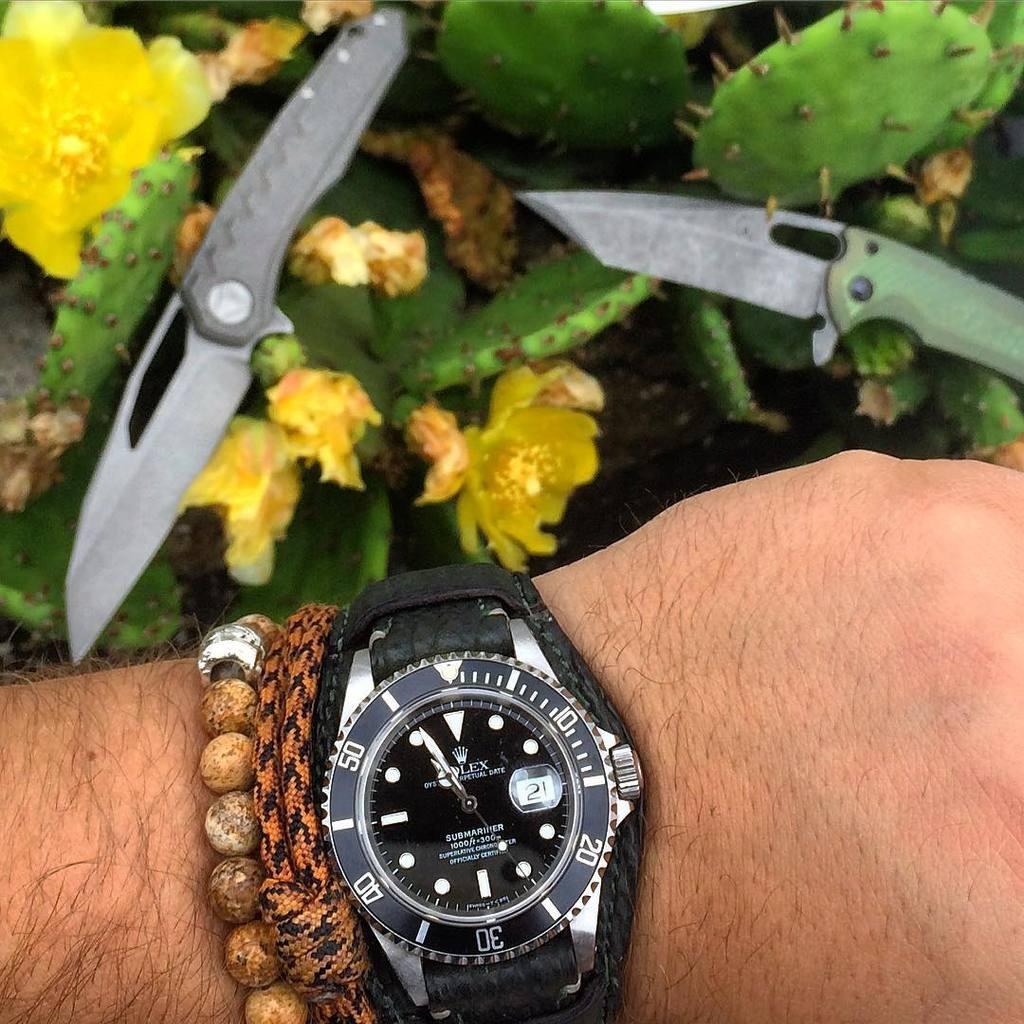<image>
Create a compact narrative representing the image presented. The watch the person is wearing is a Rolex 